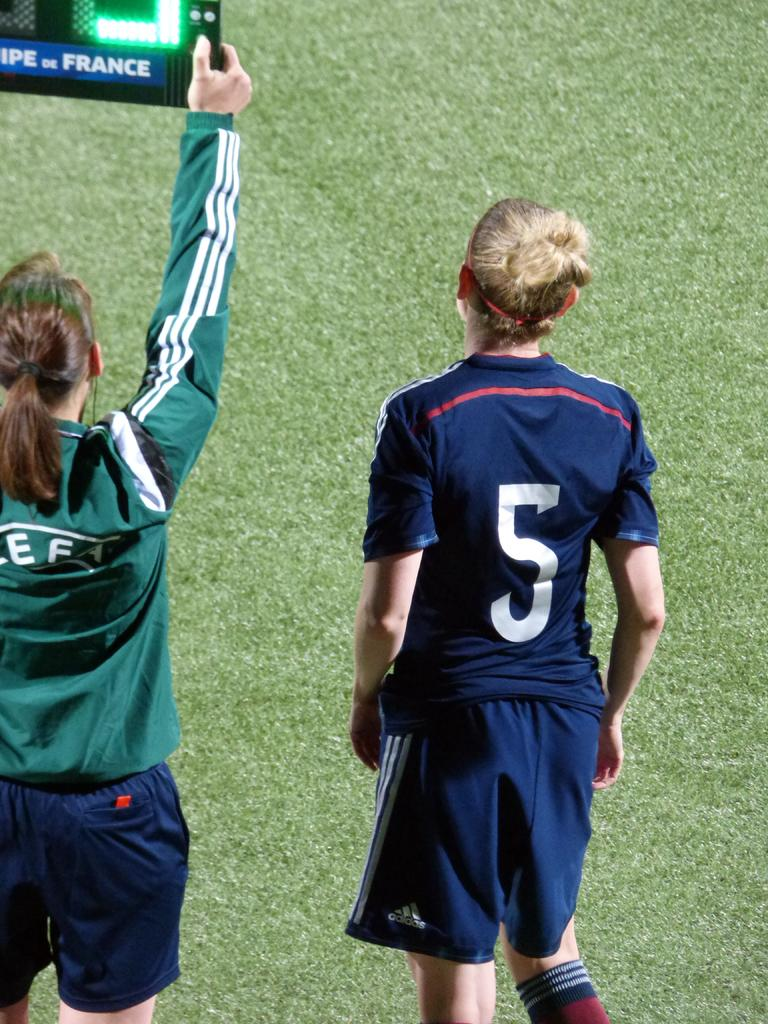<image>
Present a compact description of the photo's key features. A woman in a green shirt holds up a sign with the word France on it. 